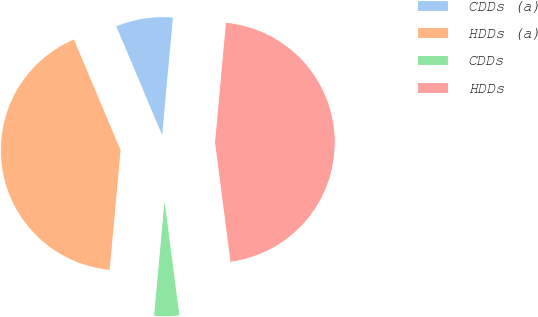<chart> <loc_0><loc_0><loc_500><loc_500><pie_chart><fcel>CDDs (a)<fcel>HDDs (a)<fcel>CDDs<fcel>HDDs<nl><fcel>7.79%<fcel>42.21%<fcel>3.5%<fcel>46.5%<nl></chart> 